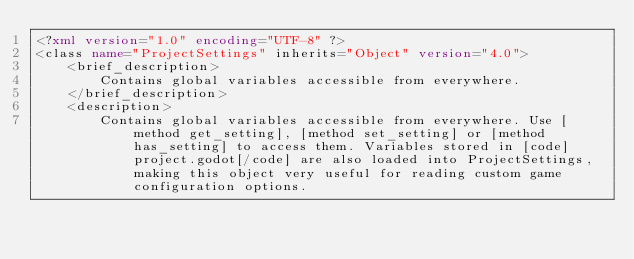<code> <loc_0><loc_0><loc_500><loc_500><_XML_><?xml version="1.0" encoding="UTF-8" ?>
<class name="ProjectSettings" inherits="Object" version="4.0">
	<brief_description>
		Contains global variables accessible from everywhere.
	</brief_description>
	<description>
		Contains global variables accessible from everywhere. Use [method get_setting], [method set_setting] or [method has_setting] to access them. Variables stored in [code]project.godot[/code] are also loaded into ProjectSettings, making this object very useful for reading custom game configuration options.</code> 